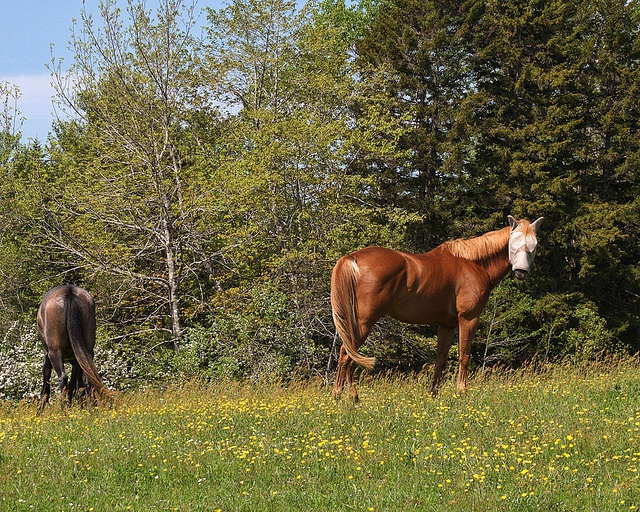Describe the objects in this image and their specific colors. I can see horse in lightblue, black, maroon, brown, and tan tones and horse in lightblue, black, gray, and maroon tones in this image. 